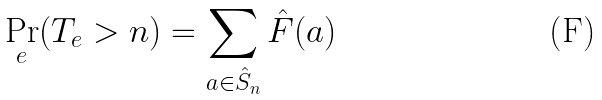Convert formula to latex. <formula><loc_0><loc_0><loc_500><loc_500>\Pr _ { e } ( T _ { e } > n ) = \sum _ { a \in \hat { S } _ { n } } \hat { F } ( a )</formula> 